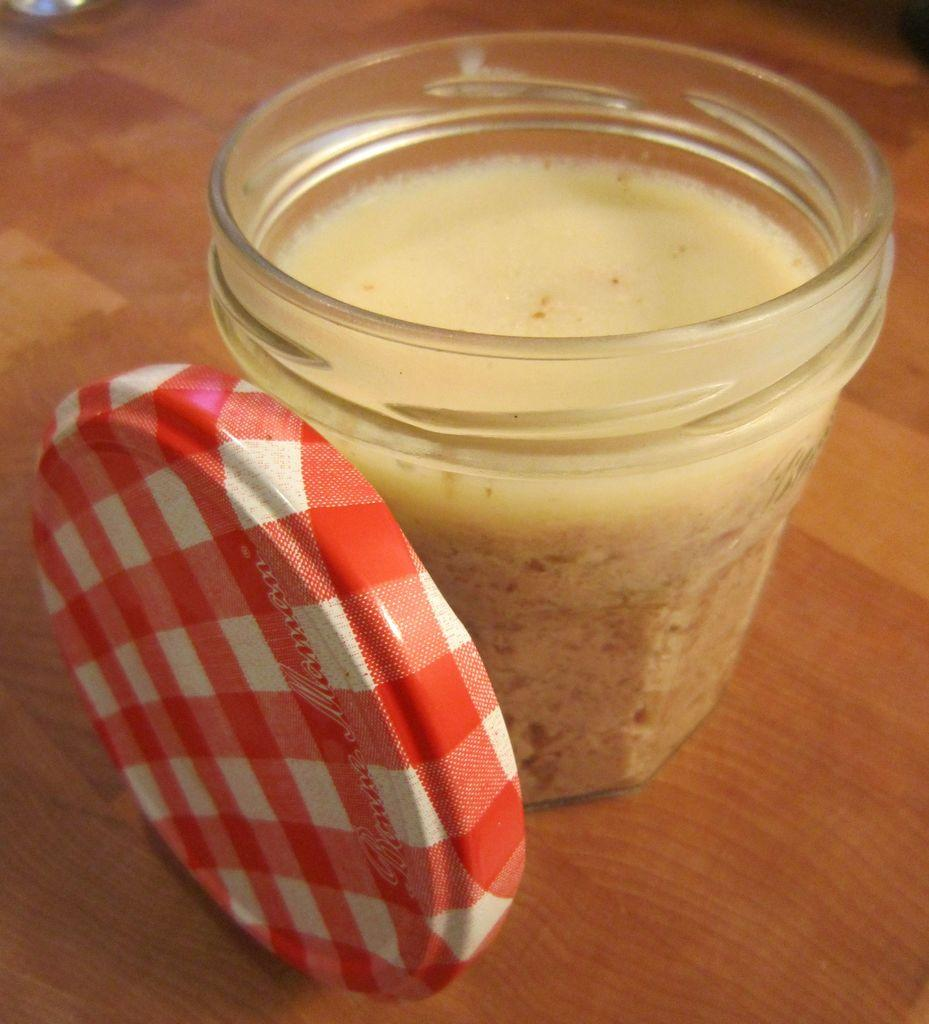What is contained in the jar that is visible in the image? There is a jar with liquid in the image. What object is on the table in the image? There is a cap on the table in the image. How many centimeters long is the snail crawling on the canvas in the image? There is no snail or canvas present in the image. What type of canvas is being used to create the artwork in the image? There is no artwork or canvas present in the image. 